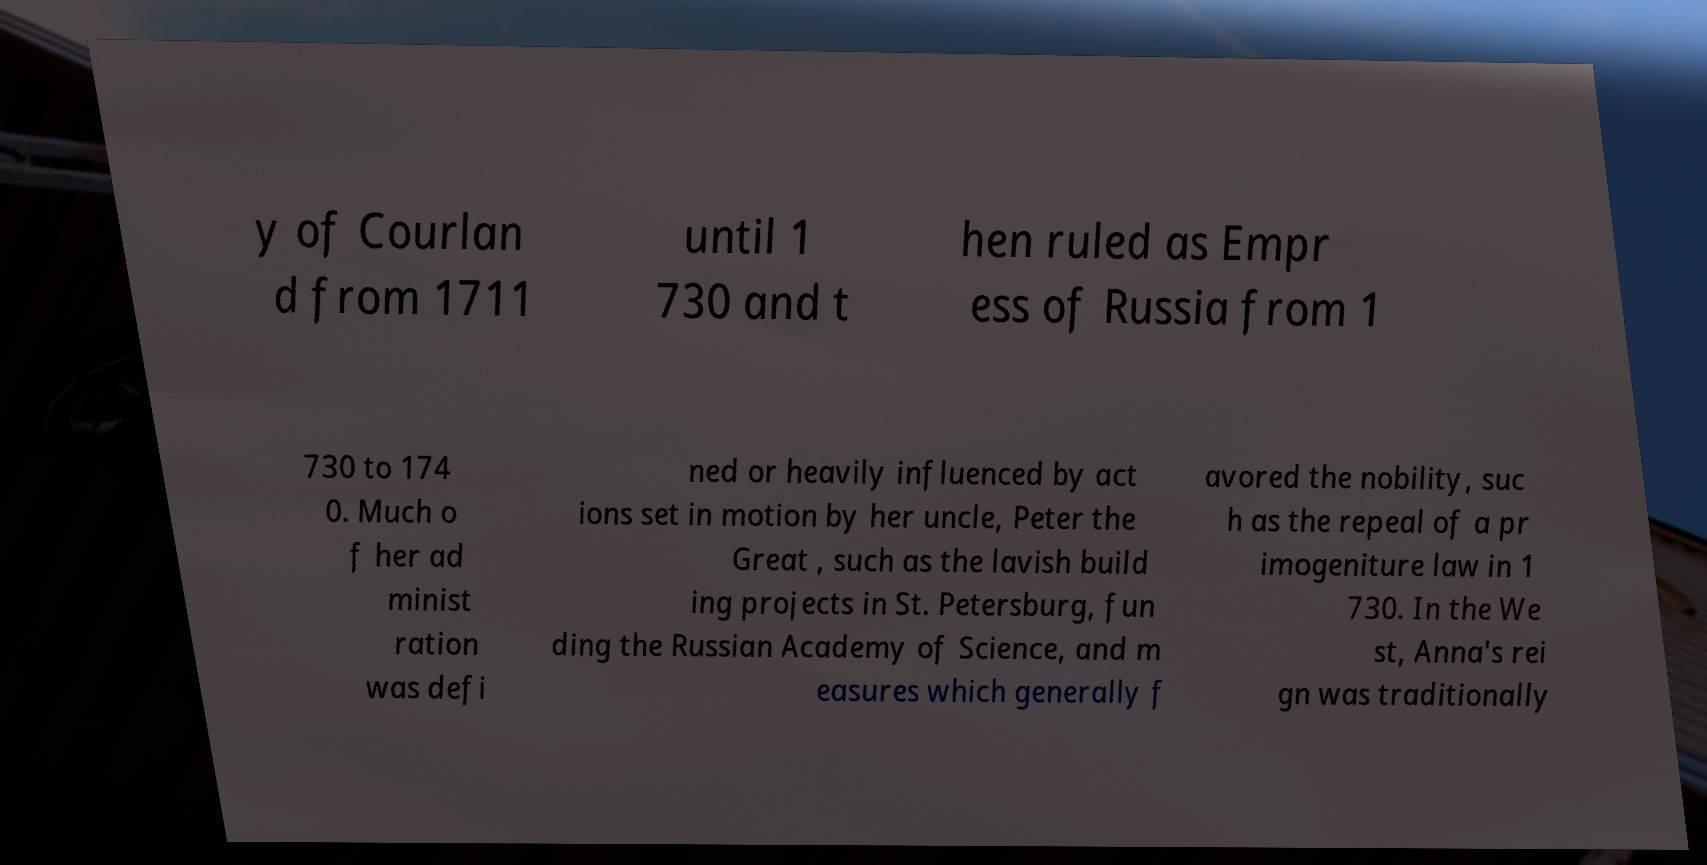Could you extract and type out the text from this image? y of Courlan d from 1711 until 1 730 and t hen ruled as Empr ess of Russia from 1 730 to 174 0. Much o f her ad minist ration was defi ned or heavily influenced by act ions set in motion by her uncle, Peter the Great , such as the lavish build ing projects in St. Petersburg, fun ding the Russian Academy of Science, and m easures which generally f avored the nobility, suc h as the repeal of a pr imogeniture law in 1 730. In the We st, Anna's rei gn was traditionally 